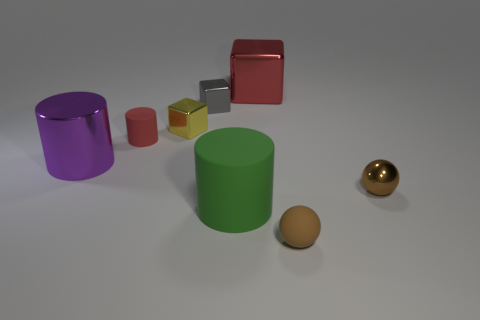Subtract all rubber cylinders. How many cylinders are left? 1 Subtract all red blocks. How many blocks are left? 2 Subtract all cylinders. How many objects are left? 5 Add 2 big gray metal balls. How many objects exist? 10 Subtract 2 balls. How many balls are left? 0 Subtract all brown blocks. Subtract all red cylinders. How many blocks are left? 3 Subtract all green blocks. How many purple cylinders are left? 1 Subtract all small balls. Subtract all tiny yellow blocks. How many objects are left? 5 Add 7 metal cylinders. How many metal cylinders are left? 8 Add 5 green rubber cylinders. How many green rubber cylinders exist? 6 